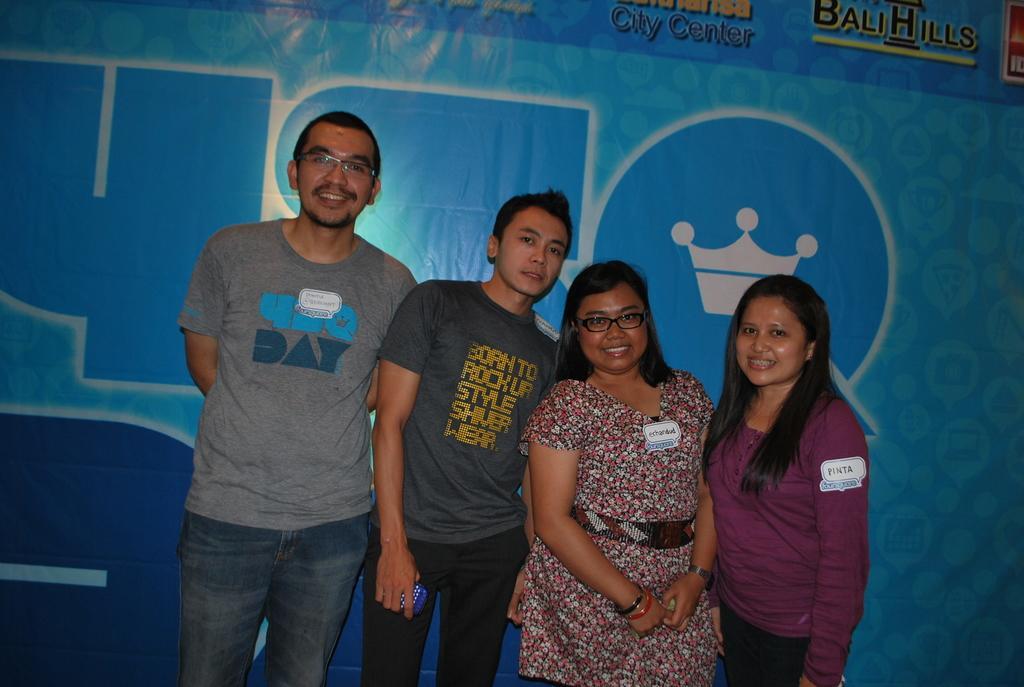How would you summarize this image in a sentence or two? In this image I can see four persons are standing and I can also see two of them are wearing specs. I can see one of them is holding a blue colour thing and expect him, I can see rest all are smiling. In the background I can see a blue colour board and on it I can see something is written. 